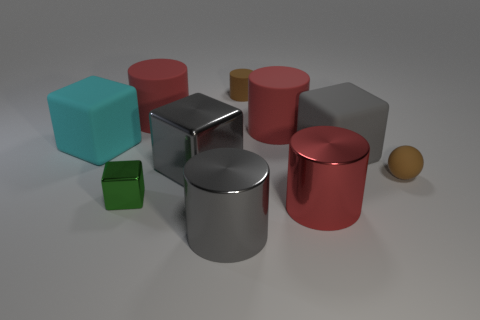Subtract all yellow balls. How many red cylinders are left? 3 Subtract all gray cylinders. How many cylinders are left? 4 Subtract all brown cylinders. How many cylinders are left? 4 Subtract all red cubes. Subtract all brown cylinders. How many cubes are left? 4 Subtract all blocks. How many objects are left? 6 Subtract 0 blue cylinders. How many objects are left? 10 Subtract all small things. Subtract all red rubber cylinders. How many objects are left? 5 Add 1 big blocks. How many big blocks are left? 4 Add 8 brown spheres. How many brown spheres exist? 9 